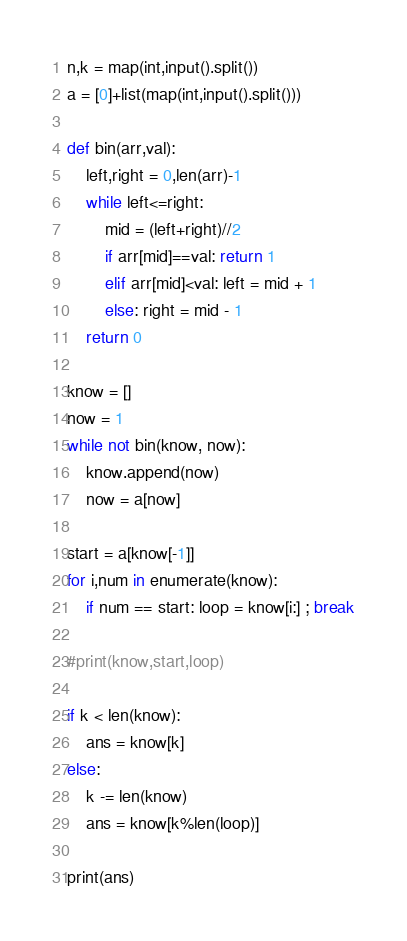<code> <loc_0><loc_0><loc_500><loc_500><_Python_>n,k = map(int,input().split())
a = [0]+list(map(int,input().split()))

def bin(arr,val):
    left,right = 0,len(arr)-1
    while left<=right:
        mid = (left+right)//2
        if arr[mid]==val: return 1
        elif arr[mid]<val: left = mid + 1
        else: right = mid - 1
    return 0

know = []
now = 1
while not bin(know, now):
    know.append(now)
    now = a[now]

start = a[know[-1]]
for i,num in enumerate(know):
    if num == start: loop = know[i:] ; break

#print(know,start,loop)

if k < len(know):
    ans = know[k]
else:
    k -= len(know)
    ans = know[k%len(loop)]

print(ans)
</code> 